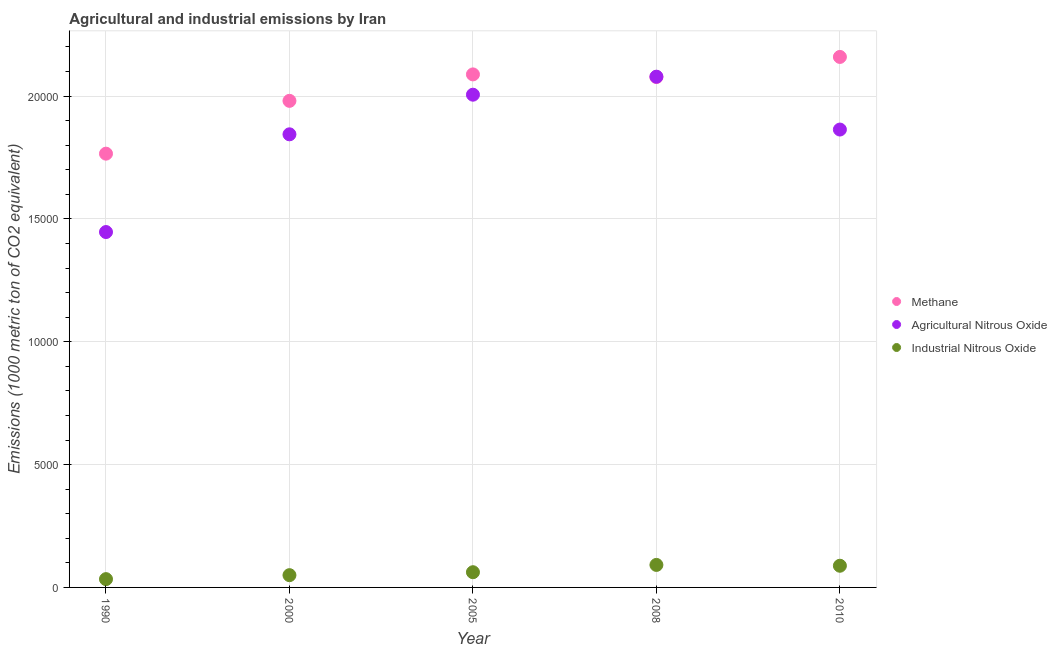What is the amount of industrial nitrous oxide emissions in 2005?
Make the answer very short. 619.4. Across all years, what is the maximum amount of agricultural nitrous oxide emissions?
Offer a very short reply. 2.08e+04. Across all years, what is the minimum amount of agricultural nitrous oxide emissions?
Your answer should be very brief. 1.45e+04. In which year was the amount of agricultural nitrous oxide emissions maximum?
Keep it short and to the point. 2008. What is the total amount of methane emissions in the graph?
Your answer should be very brief. 1.01e+05. What is the difference between the amount of industrial nitrous oxide emissions in 2005 and that in 2008?
Your answer should be very brief. -296.8. What is the difference between the amount of methane emissions in 1990 and the amount of industrial nitrous oxide emissions in 2005?
Keep it short and to the point. 1.70e+04. What is the average amount of industrial nitrous oxide emissions per year?
Make the answer very short. 651.02. In the year 2010, what is the difference between the amount of agricultural nitrous oxide emissions and amount of industrial nitrous oxide emissions?
Your answer should be very brief. 1.78e+04. In how many years, is the amount of industrial nitrous oxide emissions greater than 13000 metric ton?
Make the answer very short. 0. What is the ratio of the amount of agricultural nitrous oxide emissions in 1990 to that in 2000?
Offer a very short reply. 0.78. Is the amount of agricultural nitrous oxide emissions in 2000 less than that in 2008?
Offer a terse response. Yes. What is the difference between the highest and the second highest amount of industrial nitrous oxide emissions?
Your response must be concise. 33.7. What is the difference between the highest and the lowest amount of methane emissions?
Ensure brevity in your answer.  3937.1. Does the amount of methane emissions monotonically increase over the years?
Make the answer very short. No. Is the amount of agricultural nitrous oxide emissions strictly greater than the amount of methane emissions over the years?
Offer a very short reply. No. How many years are there in the graph?
Your response must be concise. 5. Are the values on the major ticks of Y-axis written in scientific E-notation?
Ensure brevity in your answer.  No. Does the graph contain grids?
Make the answer very short. Yes. Where does the legend appear in the graph?
Your answer should be very brief. Center right. How many legend labels are there?
Offer a very short reply. 3. What is the title of the graph?
Ensure brevity in your answer.  Agricultural and industrial emissions by Iran. What is the label or title of the Y-axis?
Provide a succinct answer. Emissions (1000 metric ton of CO2 equivalent). What is the Emissions (1000 metric ton of CO2 equivalent) of Methane in 1990?
Keep it short and to the point. 1.77e+04. What is the Emissions (1000 metric ton of CO2 equivalent) in Agricultural Nitrous Oxide in 1990?
Offer a terse response. 1.45e+04. What is the Emissions (1000 metric ton of CO2 equivalent) of Industrial Nitrous Oxide in 1990?
Your answer should be very brief. 337.6. What is the Emissions (1000 metric ton of CO2 equivalent) in Methane in 2000?
Provide a short and direct response. 1.98e+04. What is the Emissions (1000 metric ton of CO2 equivalent) in Agricultural Nitrous Oxide in 2000?
Make the answer very short. 1.84e+04. What is the Emissions (1000 metric ton of CO2 equivalent) of Industrial Nitrous Oxide in 2000?
Offer a terse response. 499.4. What is the Emissions (1000 metric ton of CO2 equivalent) in Methane in 2005?
Provide a succinct answer. 2.09e+04. What is the Emissions (1000 metric ton of CO2 equivalent) in Agricultural Nitrous Oxide in 2005?
Provide a short and direct response. 2.01e+04. What is the Emissions (1000 metric ton of CO2 equivalent) in Industrial Nitrous Oxide in 2005?
Provide a succinct answer. 619.4. What is the Emissions (1000 metric ton of CO2 equivalent) in Methane in 2008?
Give a very brief answer. 2.08e+04. What is the Emissions (1000 metric ton of CO2 equivalent) of Agricultural Nitrous Oxide in 2008?
Your response must be concise. 2.08e+04. What is the Emissions (1000 metric ton of CO2 equivalent) of Industrial Nitrous Oxide in 2008?
Give a very brief answer. 916.2. What is the Emissions (1000 metric ton of CO2 equivalent) of Methane in 2010?
Provide a short and direct response. 2.16e+04. What is the Emissions (1000 metric ton of CO2 equivalent) of Agricultural Nitrous Oxide in 2010?
Keep it short and to the point. 1.86e+04. What is the Emissions (1000 metric ton of CO2 equivalent) in Industrial Nitrous Oxide in 2010?
Offer a very short reply. 882.5. Across all years, what is the maximum Emissions (1000 metric ton of CO2 equivalent) in Methane?
Give a very brief answer. 2.16e+04. Across all years, what is the maximum Emissions (1000 metric ton of CO2 equivalent) of Agricultural Nitrous Oxide?
Your answer should be very brief. 2.08e+04. Across all years, what is the maximum Emissions (1000 metric ton of CO2 equivalent) of Industrial Nitrous Oxide?
Provide a short and direct response. 916.2. Across all years, what is the minimum Emissions (1000 metric ton of CO2 equivalent) in Methane?
Ensure brevity in your answer.  1.77e+04. Across all years, what is the minimum Emissions (1000 metric ton of CO2 equivalent) of Agricultural Nitrous Oxide?
Provide a short and direct response. 1.45e+04. Across all years, what is the minimum Emissions (1000 metric ton of CO2 equivalent) of Industrial Nitrous Oxide?
Ensure brevity in your answer.  337.6. What is the total Emissions (1000 metric ton of CO2 equivalent) in Methane in the graph?
Offer a very short reply. 1.01e+05. What is the total Emissions (1000 metric ton of CO2 equivalent) in Agricultural Nitrous Oxide in the graph?
Make the answer very short. 9.24e+04. What is the total Emissions (1000 metric ton of CO2 equivalent) of Industrial Nitrous Oxide in the graph?
Offer a terse response. 3255.1. What is the difference between the Emissions (1000 metric ton of CO2 equivalent) in Methane in 1990 and that in 2000?
Ensure brevity in your answer.  -2149.4. What is the difference between the Emissions (1000 metric ton of CO2 equivalent) in Agricultural Nitrous Oxide in 1990 and that in 2000?
Make the answer very short. -3977.6. What is the difference between the Emissions (1000 metric ton of CO2 equivalent) in Industrial Nitrous Oxide in 1990 and that in 2000?
Your answer should be very brief. -161.8. What is the difference between the Emissions (1000 metric ton of CO2 equivalent) in Methane in 1990 and that in 2005?
Your response must be concise. -3226.3. What is the difference between the Emissions (1000 metric ton of CO2 equivalent) in Agricultural Nitrous Oxide in 1990 and that in 2005?
Your answer should be very brief. -5590.3. What is the difference between the Emissions (1000 metric ton of CO2 equivalent) in Industrial Nitrous Oxide in 1990 and that in 2005?
Provide a short and direct response. -281.8. What is the difference between the Emissions (1000 metric ton of CO2 equivalent) in Methane in 1990 and that in 2008?
Make the answer very short. -3119.6. What is the difference between the Emissions (1000 metric ton of CO2 equivalent) of Agricultural Nitrous Oxide in 1990 and that in 2008?
Provide a short and direct response. -6323.6. What is the difference between the Emissions (1000 metric ton of CO2 equivalent) in Industrial Nitrous Oxide in 1990 and that in 2008?
Ensure brevity in your answer.  -578.6. What is the difference between the Emissions (1000 metric ton of CO2 equivalent) in Methane in 1990 and that in 2010?
Keep it short and to the point. -3937.1. What is the difference between the Emissions (1000 metric ton of CO2 equivalent) of Agricultural Nitrous Oxide in 1990 and that in 2010?
Make the answer very short. -4171.6. What is the difference between the Emissions (1000 metric ton of CO2 equivalent) of Industrial Nitrous Oxide in 1990 and that in 2010?
Make the answer very short. -544.9. What is the difference between the Emissions (1000 metric ton of CO2 equivalent) in Methane in 2000 and that in 2005?
Your answer should be very brief. -1076.9. What is the difference between the Emissions (1000 metric ton of CO2 equivalent) in Agricultural Nitrous Oxide in 2000 and that in 2005?
Make the answer very short. -1612.7. What is the difference between the Emissions (1000 metric ton of CO2 equivalent) in Industrial Nitrous Oxide in 2000 and that in 2005?
Offer a terse response. -120. What is the difference between the Emissions (1000 metric ton of CO2 equivalent) of Methane in 2000 and that in 2008?
Make the answer very short. -970.2. What is the difference between the Emissions (1000 metric ton of CO2 equivalent) in Agricultural Nitrous Oxide in 2000 and that in 2008?
Make the answer very short. -2346. What is the difference between the Emissions (1000 metric ton of CO2 equivalent) in Industrial Nitrous Oxide in 2000 and that in 2008?
Keep it short and to the point. -416.8. What is the difference between the Emissions (1000 metric ton of CO2 equivalent) of Methane in 2000 and that in 2010?
Keep it short and to the point. -1787.7. What is the difference between the Emissions (1000 metric ton of CO2 equivalent) in Agricultural Nitrous Oxide in 2000 and that in 2010?
Make the answer very short. -194. What is the difference between the Emissions (1000 metric ton of CO2 equivalent) of Industrial Nitrous Oxide in 2000 and that in 2010?
Offer a terse response. -383.1. What is the difference between the Emissions (1000 metric ton of CO2 equivalent) of Methane in 2005 and that in 2008?
Give a very brief answer. 106.7. What is the difference between the Emissions (1000 metric ton of CO2 equivalent) of Agricultural Nitrous Oxide in 2005 and that in 2008?
Provide a short and direct response. -733.3. What is the difference between the Emissions (1000 metric ton of CO2 equivalent) in Industrial Nitrous Oxide in 2005 and that in 2008?
Ensure brevity in your answer.  -296.8. What is the difference between the Emissions (1000 metric ton of CO2 equivalent) in Methane in 2005 and that in 2010?
Give a very brief answer. -710.8. What is the difference between the Emissions (1000 metric ton of CO2 equivalent) in Agricultural Nitrous Oxide in 2005 and that in 2010?
Ensure brevity in your answer.  1418.7. What is the difference between the Emissions (1000 metric ton of CO2 equivalent) of Industrial Nitrous Oxide in 2005 and that in 2010?
Your answer should be very brief. -263.1. What is the difference between the Emissions (1000 metric ton of CO2 equivalent) of Methane in 2008 and that in 2010?
Your answer should be very brief. -817.5. What is the difference between the Emissions (1000 metric ton of CO2 equivalent) in Agricultural Nitrous Oxide in 2008 and that in 2010?
Make the answer very short. 2152. What is the difference between the Emissions (1000 metric ton of CO2 equivalent) in Industrial Nitrous Oxide in 2008 and that in 2010?
Your answer should be very brief. 33.7. What is the difference between the Emissions (1000 metric ton of CO2 equivalent) in Methane in 1990 and the Emissions (1000 metric ton of CO2 equivalent) in Agricultural Nitrous Oxide in 2000?
Provide a succinct answer. -787.4. What is the difference between the Emissions (1000 metric ton of CO2 equivalent) in Methane in 1990 and the Emissions (1000 metric ton of CO2 equivalent) in Industrial Nitrous Oxide in 2000?
Make the answer very short. 1.72e+04. What is the difference between the Emissions (1000 metric ton of CO2 equivalent) in Agricultural Nitrous Oxide in 1990 and the Emissions (1000 metric ton of CO2 equivalent) in Industrial Nitrous Oxide in 2000?
Ensure brevity in your answer.  1.40e+04. What is the difference between the Emissions (1000 metric ton of CO2 equivalent) of Methane in 1990 and the Emissions (1000 metric ton of CO2 equivalent) of Agricultural Nitrous Oxide in 2005?
Your answer should be very brief. -2400.1. What is the difference between the Emissions (1000 metric ton of CO2 equivalent) in Methane in 1990 and the Emissions (1000 metric ton of CO2 equivalent) in Industrial Nitrous Oxide in 2005?
Ensure brevity in your answer.  1.70e+04. What is the difference between the Emissions (1000 metric ton of CO2 equivalent) in Agricultural Nitrous Oxide in 1990 and the Emissions (1000 metric ton of CO2 equivalent) in Industrial Nitrous Oxide in 2005?
Offer a very short reply. 1.38e+04. What is the difference between the Emissions (1000 metric ton of CO2 equivalent) in Methane in 1990 and the Emissions (1000 metric ton of CO2 equivalent) in Agricultural Nitrous Oxide in 2008?
Make the answer very short. -3133.4. What is the difference between the Emissions (1000 metric ton of CO2 equivalent) of Methane in 1990 and the Emissions (1000 metric ton of CO2 equivalent) of Industrial Nitrous Oxide in 2008?
Your answer should be very brief. 1.67e+04. What is the difference between the Emissions (1000 metric ton of CO2 equivalent) in Agricultural Nitrous Oxide in 1990 and the Emissions (1000 metric ton of CO2 equivalent) in Industrial Nitrous Oxide in 2008?
Provide a short and direct response. 1.35e+04. What is the difference between the Emissions (1000 metric ton of CO2 equivalent) of Methane in 1990 and the Emissions (1000 metric ton of CO2 equivalent) of Agricultural Nitrous Oxide in 2010?
Your answer should be very brief. -981.4. What is the difference between the Emissions (1000 metric ton of CO2 equivalent) in Methane in 1990 and the Emissions (1000 metric ton of CO2 equivalent) in Industrial Nitrous Oxide in 2010?
Provide a short and direct response. 1.68e+04. What is the difference between the Emissions (1000 metric ton of CO2 equivalent) of Agricultural Nitrous Oxide in 1990 and the Emissions (1000 metric ton of CO2 equivalent) of Industrial Nitrous Oxide in 2010?
Provide a succinct answer. 1.36e+04. What is the difference between the Emissions (1000 metric ton of CO2 equivalent) of Methane in 2000 and the Emissions (1000 metric ton of CO2 equivalent) of Agricultural Nitrous Oxide in 2005?
Provide a succinct answer. -250.7. What is the difference between the Emissions (1000 metric ton of CO2 equivalent) of Methane in 2000 and the Emissions (1000 metric ton of CO2 equivalent) of Industrial Nitrous Oxide in 2005?
Give a very brief answer. 1.92e+04. What is the difference between the Emissions (1000 metric ton of CO2 equivalent) in Agricultural Nitrous Oxide in 2000 and the Emissions (1000 metric ton of CO2 equivalent) in Industrial Nitrous Oxide in 2005?
Offer a very short reply. 1.78e+04. What is the difference between the Emissions (1000 metric ton of CO2 equivalent) of Methane in 2000 and the Emissions (1000 metric ton of CO2 equivalent) of Agricultural Nitrous Oxide in 2008?
Offer a terse response. -984. What is the difference between the Emissions (1000 metric ton of CO2 equivalent) in Methane in 2000 and the Emissions (1000 metric ton of CO2 equivalent) in Industrial Nitrous Oxide in 2008?
Give a very brief answer. 1.89e+04. What is the difference between the Emissions (1000 metric ton of CO2 equivalent) of Agricultural Nitrous Oxide in 2000 and the Emissions (1000 metric ton of CO2 equivalent) of Industrial Nitrous Oxide in 2008?
Provide a succinct answer. 1.75e+04. What is the difference between the Emissions (1000 metric ton of CO2 equivalent) in Methane in 2000 and the Emissions (1000 metric ton of CO2 equivalent) in Agricultural Nitrous Oxide in 2010?
Keep it short and to the point. 1168. What is the difference between the Emissions (1000 metric ton of CO2 equivalent) of Methane in 2000 and the Emissions (1000 metric ton of CO2 equivalent) of Industrial Nitrous Oxide in 2010?
Your answer should be compact. 1.89e+04. What is the difference between the Emissions (1000 metric ton of CO2 equivalent) in Agricultural Nitrous Oxide in 2000 and the Emissions (1000 metric ton of CO2 equivalent) in Industrial Nitrous Oxide in 2010?
Your answer should be compact. 1.76e+04. What is the difference between the Emissions (1000 metric ton of CO2 equivalent) of Methane in 2005 and the Emissions (1000 metric ton of CO2 equivalent) of Agricultural Nitrous Oxide in 2008?
Provide a short and direct response. 92.9. What is the difference between the Emissions (1000 metric ton of CO2 equivalent) in Methane in 2005 and the Emissions (1000 metric ton of CO2 equivalent) in Industrial Nitrous Oxide in 2008?
Provide a short and direct response. 2.00e+04. What is the difference between the Emissions (1000 metric ton of CO2 equivalent) of Agricultural Nitrous Oxide in 2005 and the Emissions (1000 metric ton of CO2 equivalent) of Industrial Nitrous Oxide in 2008?
Provide a short and direct response. 1.91e+04. What is the difference between the Emissions (1000 metric ton of CO2 equivalent) of Methane in 2005 and the Emissions (1000 metric ton of CO2 equivalent) of Agricultural Nitrous Oxide in 2010?
Ensure brevity in your answer.  2244.9. What is the difference between the Emissions (1000 metric ton of CO2 equivalent) in Methane in 2005 and the Emissions (1000 metric ton of CO2 equivalent) in Industrial Nitrous Oxide in 2010?
Give a very brief answer. 2.00e+04. What is the difference between the Emissions (1000 metric ton of CO2 equivalent) in Agricultural Nitrous Oxide in 2005 and the Emissions (1000 metric ton of CO2 equivalent) in Industrial Nitrous Oxide in 2010?
Offer a very short reply. 1.92e+04. What is the difference between the Emissions (1000 metric ton of CO2 equivalent) in Methane in 2008 and the Emissions (1000 metric ton of CO2 equivalent) in Agricultural Nitrous Oxide in 2010?
Your answer should be compact. 2138.2. What is the difference between the Emissions (1000 metric ton of CO2 equivalent) of Methane in 2008 and the Emissions (1000 metric ton of CO2 equivalent) of Industrial Nitrous Oxide in 2010?
Offer a terse response. 1.99e+04. What is the difference between the Emissions (1000 metric ton of CO2 equivalent) of Agricultural Nitrous Oxide in 2008 and the Emissions (1000 metric ton of CO2 equivalent) of Industrial Nitrous Oxide in 2010?
Provide a succinct answer. 1.99e+04. What is the average Emissions (1000 metric ton of CO2 equivalent) in Methane per year?
Give a very brief answer. 2.01e+04. What is the average Emissions (1000 metric ton of CO2 equivalent) of Agricultural Nitrous Oxide per year?
Offer a very short reply. 1.85e+04. What is the average Emissions (1000 metric ton of CO2 equivalent) in Industrial Nitrous Oxide per year?
Your response must be concise. 651.02. In the year 1990, what is the difference between the Emissions (1000 metric ton of CO2 equivalent) of Methane and Emissions (1000 metric ton of CO2 equivalent) of Agricultural Nitrous Oxide?
Provide a short and direct response. 3190.2. In the year 1990, what is the difference between the Emissions (1000 metric ton of CO2 equivalent) of Methane and Emissions (1000 metric ton of CO2 equivalent) of Industrial Nitrous Oxide?
Your response must be concise. 1.73e+04. In the year 1990, what is the difference between the Emissions (1000 metric ton of CO2 equivalent) of Agricultural Nitrous Oxide and Emissions (1000 metric ton of CO2 equivalent) of Industrial Nitrous Oxide?
Offer a terse response. 1.41e+04. In the year 2000, what is the difference between the Emissions (1000 metric ton of CO2 equivalent) in Methane and Emissions (1000 metric ton of CO2 equivalent) in Agricultural Nitrous Oxide?
Give a very brief answer. 1362. In the year 2000, what is the difference between the Emissions (1000 metric ton of CO2 equivalent) in Methane and Emissions (1000 metric ton of CO2 equivalent) in Industrial Nitrous Oxide?
Provide a succinct answer. 1.93e+04. In the year 2000, what is the difference between the Emissions (1000 metric ton of CO2 equivalent) of Agricultural Nitrous Oxide and Emissions (1000 metric ton of CO2 equivalent) of Industrial Nitrous Oxide?
Provide a succinct answer. 1.79e+04. In the year 2005, what is the difference between the Emissions (1000 metric ton of CO2 equivalent) in Methane and Emissions (1000 metric ton of CO2 equivalent) in Agricultural Nitrous Oxide?
Your answer should be compact. 826.2. In the year 2005, what is the difference between the Emissions (1000 metric ton of CO2 equivalent) of Methane and Emissions (1000 metric ton of CO2 equivalent) of Industrial Nitrous Oxide?
Give a very brief answer. 2.03e+04. In the year 2005, what is the difference between the Emissions (1000 metric ton of CO2 equivalent) in Agricultural Nitrous Oxide and Emissions (1000 metric ton of CO2 equivalent) in Industrial Nitrous Oxide?
Offer a terse response. 1.94e+04. In the year 2008, what is the difference between the Emissions (1000 metric ton of CO2 equivalent) in Methane and Emissions (1000 metric ton of CO2 equivalent) in Industrial Nitrous Oxide?
Provide a short and direct response. 1.99e+04. In the year 2008, what is the difference between the Emissions (1000 metric ton of CO2 equivalent) in Agricultural Nitrous Oxide and Emissions (1000 metric ton of CO2 equivalent) in Industrial Nitrous Oxide?
Give a very brief answer. 1.99e+04. In the year 2010, what is the difference between the Emissions (1000 metric ton of CO2 equivalent) in Methane and Emissions (1000 metric ton of CO2 equivalent) in Agricultural Nitrous Oxide?
Your response must be concise. 2955.7. In the year 2010, what is the difference between the Emissions (1000 metric ton of CO2 equivalent) of Methane and Emissions (1000 metric ton of CO2 equivalent) of Industrial Nitrous Oxide?
Offer a terse response. 2.07e+04. In the year 2010, what is the difference between the Emissions (1000 metric ton of CO2 equivalent) of Agricultural Nitrous Oxide and Emissions (1000 metric ton of CO2 equivalent) of Industrial Nitrous Oxide?
Provide a succinct answer. 1.78e+04. What is the ratio of the Emissions (1000 metric ton of CO2 equivalent) of Methane in 1990 to that in 2000?
Offer a terse response. 0.89. What is the ratio of the Emissions (1000 metric ton of CO2 equivalent) in Agricultural Nitrous Oxide in 1990 to that in 2000?
Your response must be concise. 0.78. What is the ratio of the Emissions (1000 metric ton of CO2 equivalent) in Industrial Nitrous Oxide in 1990 to that in 2000?
Offer a terse response. 0.68. What is the ratio of the Emissions (1000 metric ton of CO2 equivalent) in Methane in 1990 to that in 2005?
Offer a very short reply. 0.85. What is the ratio of the Emissions (1000 metric ton of CO2 equivalent) of Agricultural Nitrous Oxide in 1990 to that in 2005?
Provide a succinct answer. 0.72. What is the ratio of the Emissions (1000 metric ton of CO2 equivalent) in Industrial Nitrous Oxide in 1990 to that in 2005?
Make the answer very short. 0.55. What is the ratio of the Emissions (1000 metric ton of CO2 equivalent) of Methane in 1990 to that in 2008?
Provide a short and direct response. 0.85. What is the ratio of the Emissions (1000 metric ton of CO2 equivalent) in Agricultural Nitrous Oxide in 1990 to that in 2008?
Offer a terse response. 0.7. What is the ratio of the Emissions (1000 metric ton of CO2 equivalent) of Industrial Nitrous Oxide in 1990 to that in 2008?
Offer a very short reply. 0.37. What is the ratio of the Emissions (1000 metric ton of CO2 equivalent) of Methane in 1990 to that in 2010?
Make the answer very short. 0.82. What is the ratio of the Emissions (1000 metric ton of CO2 equivalent) of Agricultural Nitrous Oxide in 1990 to that in 2010?
Offer a very short reply. 0.78. What is the ratio of the Emissions (1000 metric ton of CO2 equivalent) in Industrial Nitrous Oxide in 1990 to that in 2010?
Your answer should be compact. 0.38. What is the ratio of the Emissions (1000 metric ton of CO2 equivalent) in Methane in 2000 to that in 2005?
Give a very brief answer. 0.95. What is the ratio of the Emissions (1000 metric ton of CO2 equivalent) of Agricultural Nitrous Oxide in 2000 to that in 2005?
Make the answer very short. 0.92. What is the ratio of the Emissions (1000 metric ton of CO2 equivalent) in Industrial Nitrous Oxide in 2000 to that in 2005?
Ensure brevity in your answer.  0.81. What is the ratio of the Emissions (1000 metric ton of CO2 equivalent) of Methane in 2000 to that in 2008?
Ensure brevity in your answer.  0.95. What is the ratio of the Emissions (1000 metric ton of CO2 equivalent) of Agricultural Nitrous Oxide in 2000 to that in 2008?
Give a very brief answer. 0.89. What is the ratio of the Emissions (1000 metric ton of CO2 equivalent) in Industrial Nitrous Oxide in 2000 to that in 2008?
Offer a terse response. 0.55. What is the ratio of the Emissions (1000 metric ton of CO2 equivalent) of Methane in 2000 to that in 2010?
Ensure brevity in your answer.  0.92. What is the ratio of the Emissions (1000 metric ton of CO2 equivalent) in Agricultural Nitrous Oxide in 2000 to that in 2010?
Give a very brief answer. 0.99. What is the ratio of the Emissions (1000 metric ton of CO2 equivalent) in Industrial Nitrous Oxide in 2000 to that in 2010?
Provide a succinct answer. 0.57. What is the ratio of the Emissions (1000 metric ton of CO2 equivalent) in Methane in 2005 to that in 2008?
Provide a succinct answer. 1.01. What is the ratio of the Emissions (1000 metric ton of CO2 equivalent) in Agricultural Nitrous Oxide in 2005 to that in 2008?
Ensure brevity in your answer.  0.96. What is the ratio of the Emissions (1000 metric ton of CO2 equivalent) of Industrial Nitrous Oxide in 2005 to that in 2008?
Ensure brevity in your answer.  0.68. What is the ratio of the Emissions (1000 metric ton of CO2 equivalent) in Methane in 2005 to that in 2010?
Your answer should be compact. 0.97. What is the ratio of the Emissions (1000 metric ton of CO2 equivalent) in Agricultural Nitrous Oxide in 2005 to that in 2010?
Your answer should be compact. 1.08. What is the ratio of the Emissions (1000 metric ton of CO2 equivalent) of Industrial Nitrous Oxide in 2005 to that in 2010?
Make the answer very short. 0.7. What is the ratio of the Emissions (1000 metric ton of CO2 equivalent) in Methane in 2008 to that in 2010?
Make the answer very short. 0.96. What is the ratio of the Emissions (1000 metric ton of CO2 equivalent) of Agricultural Nitrous Oxide in 2008 to that in 2010?
Provide a short and direct response. 1.12. What is the ratio of the Emissions (1000 metric ton of CO2 equivalent) of Industrial Nitrous Oxide in 2008 to that in 2010?
Offer a very short reply. 1.04. What is the difference between the highest and the second highest Emissions (1000 metric ton of CO2 equivalent) in Methane?
Offer a terse response. 710.8. What is the difference between the highest and the second highest Emissions (1000 metric ton of CO2 equivalent) of Agricultural Nitrous Oxide?
Keep it short and to the point. 733.3. What is the difference between the highest and the second highest Emissions (1000 metric ton of CO2 equivalent) of Industrial Nitrous Oxide?
Make the answer very short. 33.7. What is the difference between the highest and the lowest Emissions (1000 metric ton of CO2 equivalent) in Methane?
Offer a terse response. 3937.1. What is the difference between the highest and the lowest Emissions (1000 metric ton of CO2 equivalent) of Agricultural Nitrous Oxide?
Make the answer very short. 6323.6. What is the difference between the highest and the lowest Emissions (1000 metric ton of CO2 equivalent) of Industrial Nitrous Oxide?
Make the answer very short. 578.6. 